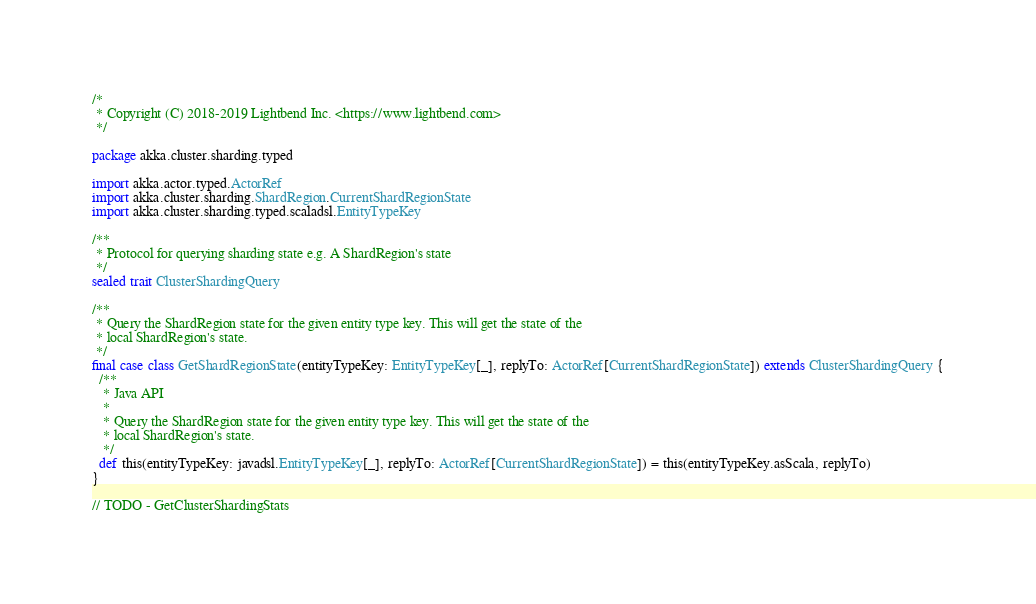<code> <loc_0><loc_0><loc_500><loc_500><_Scala_>/*
 * Copyright (C) 2018-2019 Lightbend Inc. <https://www.lightbend.com>
 */

package akka.cluster.sharding.typed

import akka.actor.typed.ActorRef
import akka.cluster.sharding.ShardRegion.CurrentShardRegionState
import akka.cluster.sharding.typed.scaladsl.EntityTypeKey

/**
 * Protocol for querying sharding state e.g. A ShardRegion's state
 */
sealed trait ClusterShardingQuery

/**
 * Query the ShardRegion state for the given entity type key. This will get the state of the
 * local ShardRegion's state.
 */
final case class GetShardRegionState(entityTypeKey: EntityTypeKey[_], replyTo: ActorRef[CurrentShardRegionState]) extends ClusterShardingQuery {
  /**
   * Java API
   *
   * Query the ShardRegion state for the given entity type key. This will get the state of the
   * local ShardRegion's state.
   */
  def this(entityTypeKey: javadsl.EntityTypeKey[_], replyTo: ActorRef[CurrentShardRegionState]) = this(entityTypeKey.asScala, replyTo)
}

// TODO - GetClusterShardingStats

</code> 